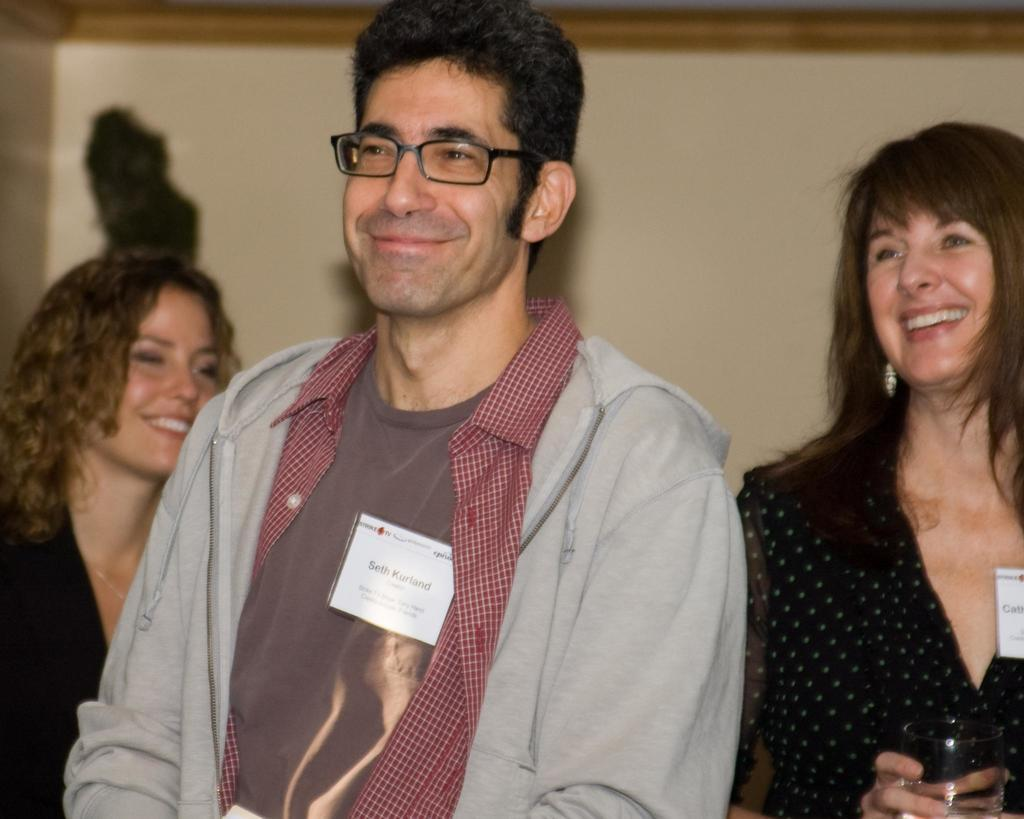What is the appearance of the man in the image? There is a man with spectacles in the image. What is the man's expression in the image? The man is smiling. Can you describe the people in the background of the image? There are two persons smiling in the background of the image, and one of them is holding a glass. What type of crib is visible in the image? There is no crib present in the image. 